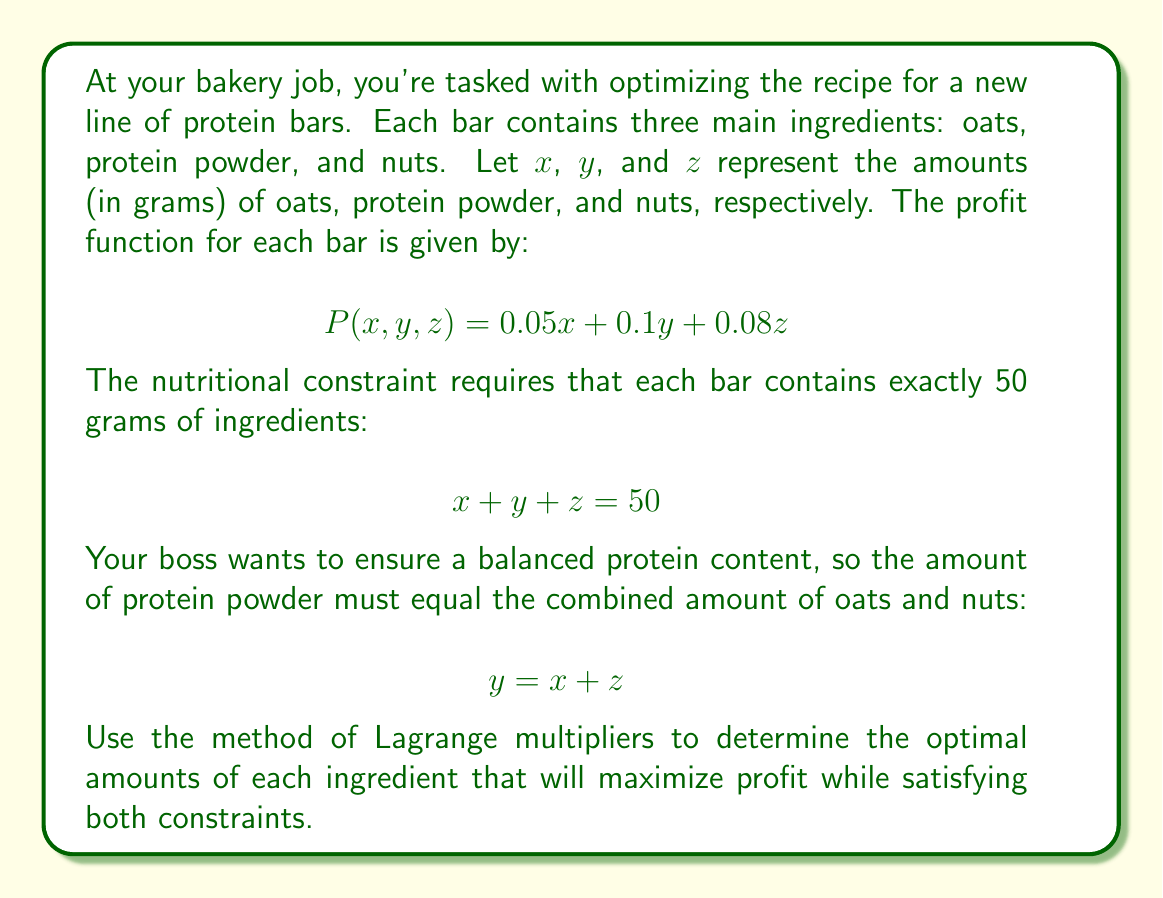Help me with this question. Let's approach this problem step-by-step using the method of Lagrange multipliers:

1) First, we define the Lagrangian function with two multipliers, $\lambda_1$ and $\lambda_2$:

   $$L(x,y,z,\lambda_1,\lambda_2) = 0.05x + 0.1y + 0.08z + \lambda_1(50 - x - y - z) + \lambda_2(y - x - z)$$

2) Now, we take partial derivatives of $L$ with respect to each variable and set them equal to zero:

   $$\frac{\partial L}{\partial x} = 0.05 - \lambda_1 - \lambda_2 = 0$$
   $$\frac{\partial L}{\partial y} = 0.1 - \lambda_1 + \lambda_2 = 0$$
   $$\frac{\partial L}{\partial z} = 0.08 - \lambda_1 - \lambda_2 = 0$$
   $$\frac{\partial L}{\partial \lambda_1} = 50 - x - y - z = 0$$
   $$\frac{\partial L}{\partial \lambda_2} = y - x - z = 0$$

3) From the first and third equations:
   
   $$0.05 - \lambda_1 - \lambda_2 = 0.08 - \lambda_1 - \lambda_2$$
   $$0.05 = 0.08$$

   This is a contradiction, so $x$ and $z$ cannot be different.

4) Let $x = z = a$. Then from the last equation:
   
   $$y = x + z = 2a$$

5) Substituting into the fourth equation:

   $$a + 2a + a = 50$$
   $$4a = 50$$
   $$a = 12.5$$

6) Therefore:
   
   $$x = z = 12.5$$
   $$y = 25$$

7) We can verify that this satisfies both constraints:
   
   $$12.5 + 25 + 12.5 = 50$$
   $$25 = 12.5 + 12.5$$

8) The maximum profit is:

   $$P(12.5, 25, 12.5) = 0.05(12.5) + 0.1(25) + 0.08(12.5) = 3.625$$
Answer: The optimal amounts are 12.5g of oats, 25g of protein powder, and 12.5g of nuts. The maximum profit per bar is $3.625. 